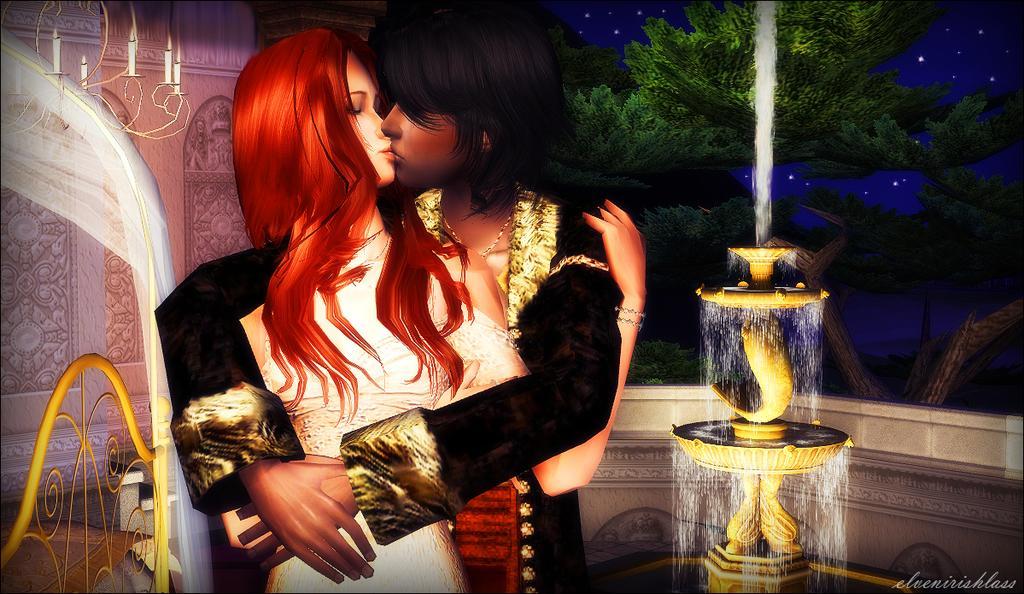Describe this image in one or two sentences. In the center of the image there is a depiction of a man and a woman. In the background of the image there are trees. There is a fountain. 